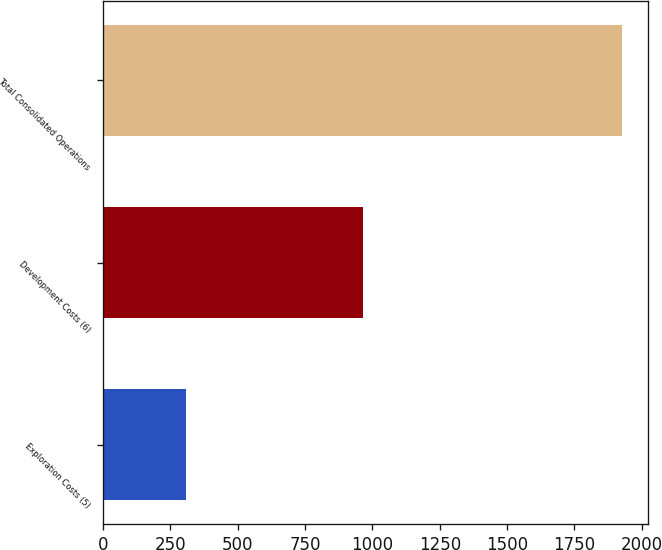Convert chart. <chart><loc_0><loc_0><loc_500><loc_500><bar_chart><fcel>Exploration Costs (5)<fcel>Development Costs (6)<fcel>Total Consolidated Operations<nl><fcel>306<fcel>964<fcel>1926<nl></chart> 